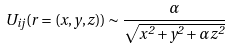Convert formula to latex. <formula><loc_0><loc_0><loc_500><loc_500>U _ { i j } ( { r } = ( x , y , z ) ) \sim \frac { \alpha } { \sqrt { x ^ { 2 } + y ^ { 2 } + \alpha z ^ { 2 } } }</formula> 